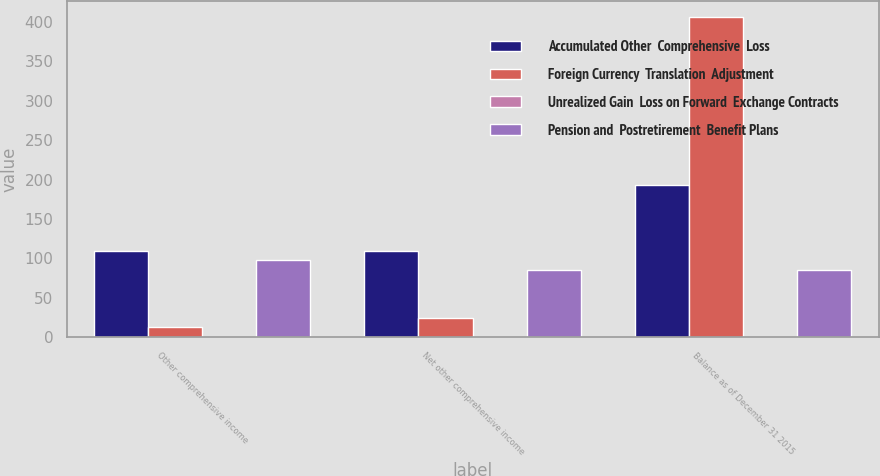Convert chart to OTSL. <chart><loc_0><loc_0><loc_500><loc_500><stacked_bar_chart><ecel><fcel>Other comprehensive income<fcel>Net other comprehensive income<fcel>Balance as of December 31 2015<nl><fcel>Accumulated Other  Comprehensive  Loss<fcel>110<fcel>110<fcel>193<nl><fcel>Foreign Currency  Translation  Adjustment<fcel>13<fcel>25<fcel>406<nl><fcel>Unrealized Gain  Loss on Forward  Exchange Contracts<fcel>1<fcel>1<fcel>1<nl><fcel>Pension and  Postretirement  Benefit Plans<fcel>98<fcel>86<fcel>86<nl></chart> 